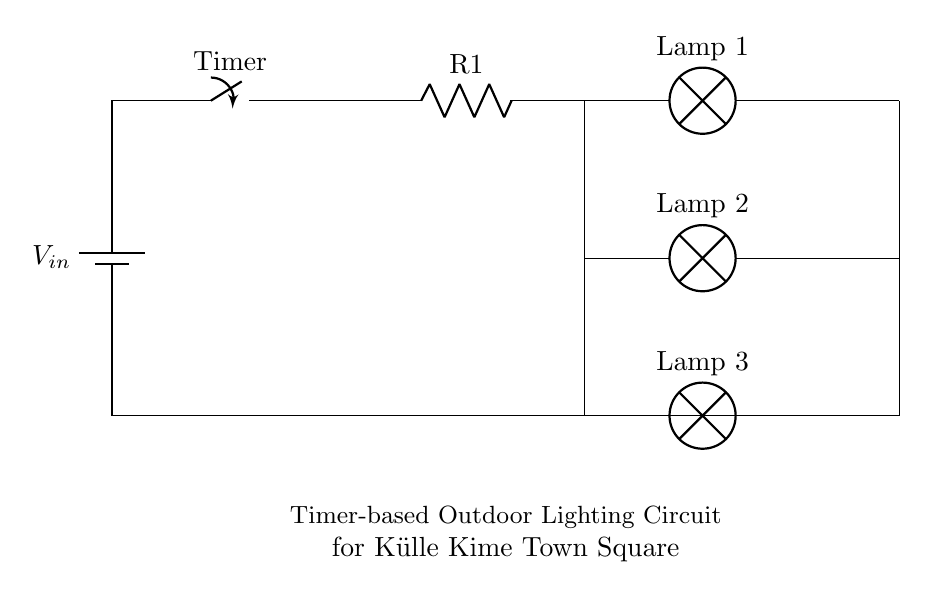What is the input voltage for this circuit? The input voltage is indicated as V in the circuit diagram. It is represented by the battery symbol.
Answer: V in What components are used in this timer-based circuit? The circuit includes a timer, three lamps, a resistor, and a battery. These are essential components required for this incandescent lighting control system.
Answer: Timer, lamps, resistor, battery How many lamps are connected to the circuit? There are three lamps connected in total, as shown by the three separate lamp symbols in the diagram.
Answer: Three What role does the timer play in this circuit? The timer controls the activation and deactivation of the lamps based on a set time interval, making it essential for outdoor lighting management.
Answer: Controls lighting duration What is the position of the resistor in the circuit? The resistor is connected in series with the timer and the three lamps, which suggests that it regulates the current through these components.
Answer: After the timer Are the lamps connected in series or parallel with each other? The lamps are connected in parallel, as they have their own branches leading from the same voltage source, allowing them to operate independently.
Answer: Parallel 